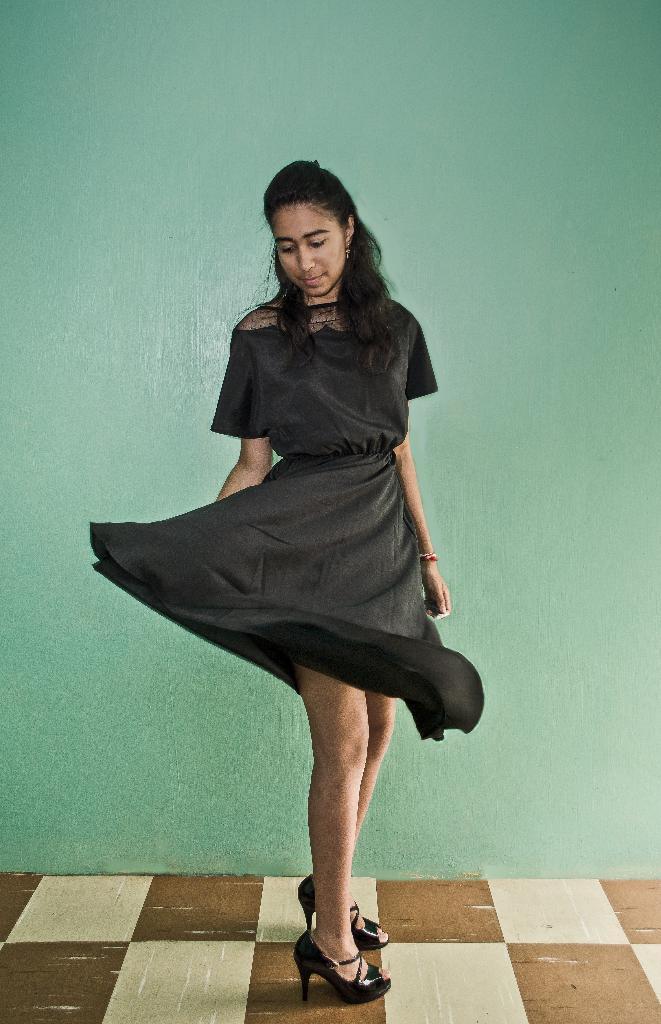Could you give a brief overview of what you see in this image? In this image we can see a girl is standing. She is wearing black color dress and black color sandal. Behind her green color wall is there. 